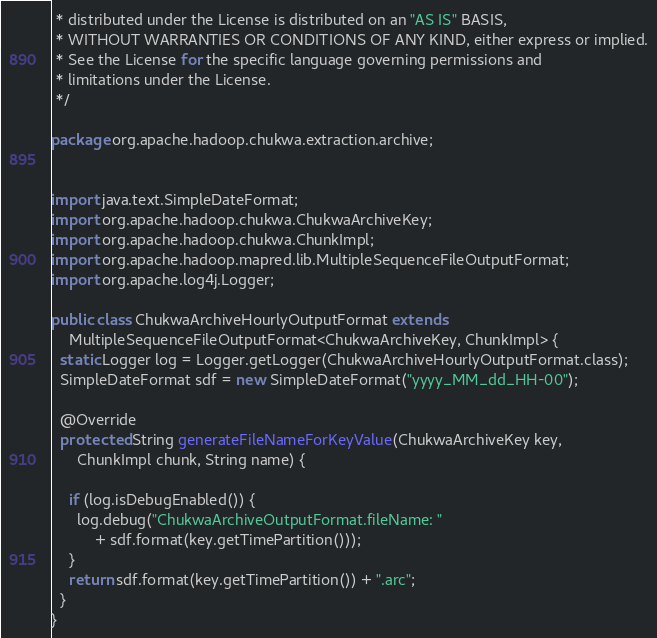Convert code to text. <code><loc_0><loc_0><loc_500><loc_500><_Java_> * distributed under the License is distributed on an "AS IS" BASIS,
 * WITHOUT WARRANTIES OR CONDITIONS OF ANY KIND, either express or implied.
 * See the License for the specific language governing permissions and
 * limitations under the License.
 */

package org.apache.hadoop.chukwa.extraction.archive;


import java.text.SimpleDateFormat;
import org.apache.hadoop.chukwa.ChukwaArchiveKey;
import org.apache.hadoop.chukwa.ChunkImpl;
import org.apache.hadoop.mapred.lib.MultipleSequenceFileOutputFormat;
import org.apache.log4j.Logger;

public class ChukwaArchiveHourlyOutputFormat extends
    MultipleSequenceFileOutputFormat<ChukwaArchiveKey, ChunkImpl> {
  static Logger log = Logger.getLogger(ChukwaArchiveHourlyOutputFormat.class);
  SimpleDateFormat sdf = new SimpleDateFormat("yyyy_MM_dd_HH-00");

  @Override
  protected String generateFileNameForKeyValue(ChukwaArchiveKey key,
      ChunkImpl chunk, String name) {

    if (log.isDebugEnabled()) {
      log.debug("ChukwaArchiveOutputFormat.fileName: "
          + sdf.format(key.getTimePartition()));
    }
    return sdf.format(key.getTimePartition()) + ".arc";
  }
}
</code> 